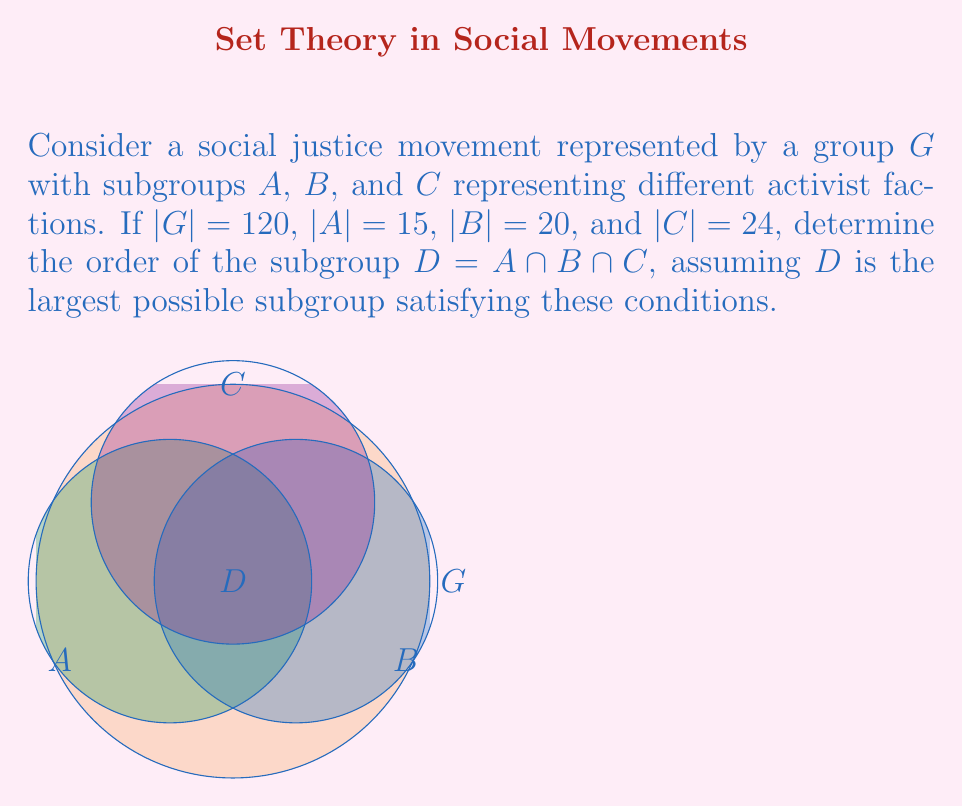Give your solution to this math problem. Let's approach this step-by-step using group theory concepts:

1) First, recall Lagrange's theorem: the order of a subgroup must divide the order of the group. So, all subgroup orders must divide 120.

2) The greatest common divisor of 15, 20, and 24 will give us the largest possible order for subgroup $D$:

   $\gcd(15, 20, 24) = \gcd(\gcd(15, 20), 24) = \gcd(5, 24) = 1$

3) This means that the largest possible order for $D$ is 1.

4) To confirm this result, we can use the Inclusion-Exclusion Principle:

   $|A \cup B \cup C| = |A| + |B| + |C| - |A \cap B| - |B \cap C| - |A \cap C| + |A \cap B \cap C|$

5) We know that $|A \cup B \cup C| \leq |G| = 120$. Let's assume $|D| = |A \cap B \cap C| = 1$ and see if this satisfies the inequality:

   $120 \geq 15 + 20 + 24 - |A \cap B| - |B \cap C| - |A \cap C| + 1$

6) The smallest possible values for $|A \cap B|$, $|B \cap C|$, and $|A \cap C|$ that satisfy Lagrange's theorem are 5, 4, and 3 respectively.

7) Substituting these values:

   $120 \geq 15 + 20 + 24 - 5 - 4 - 3 + 1 = 48$

8) This inequality holds true, confirming that $|D| = 1$ is indeed possible and is the largest possible order for $D$.
Answer: $|D| = 1$ 